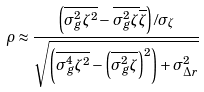Convert formula to latex. <formula><loc_0><loc_0><loc_500><loc_500>\rho \approx \frac { \left ( \overline { \sigma _ { g } ^ { 2 } \zeta ^ { 2 } } - \overline { \sigma _ { g } ^ { 2 } \zeta } \overline { \zeta } \right ) / \sigma _ { \zeta } } { \sqrt { \left ( \overline { \sigma _ { g } ^ { 4 } \zeta ^ { 2 } } - \left ( \overline { \sigma _ { g } ^ { 2 } \zeta } \right ) ^ { 2 } \right ) + \sigma _ { \Delta r } ^ { 2 } } } \\</formula> 